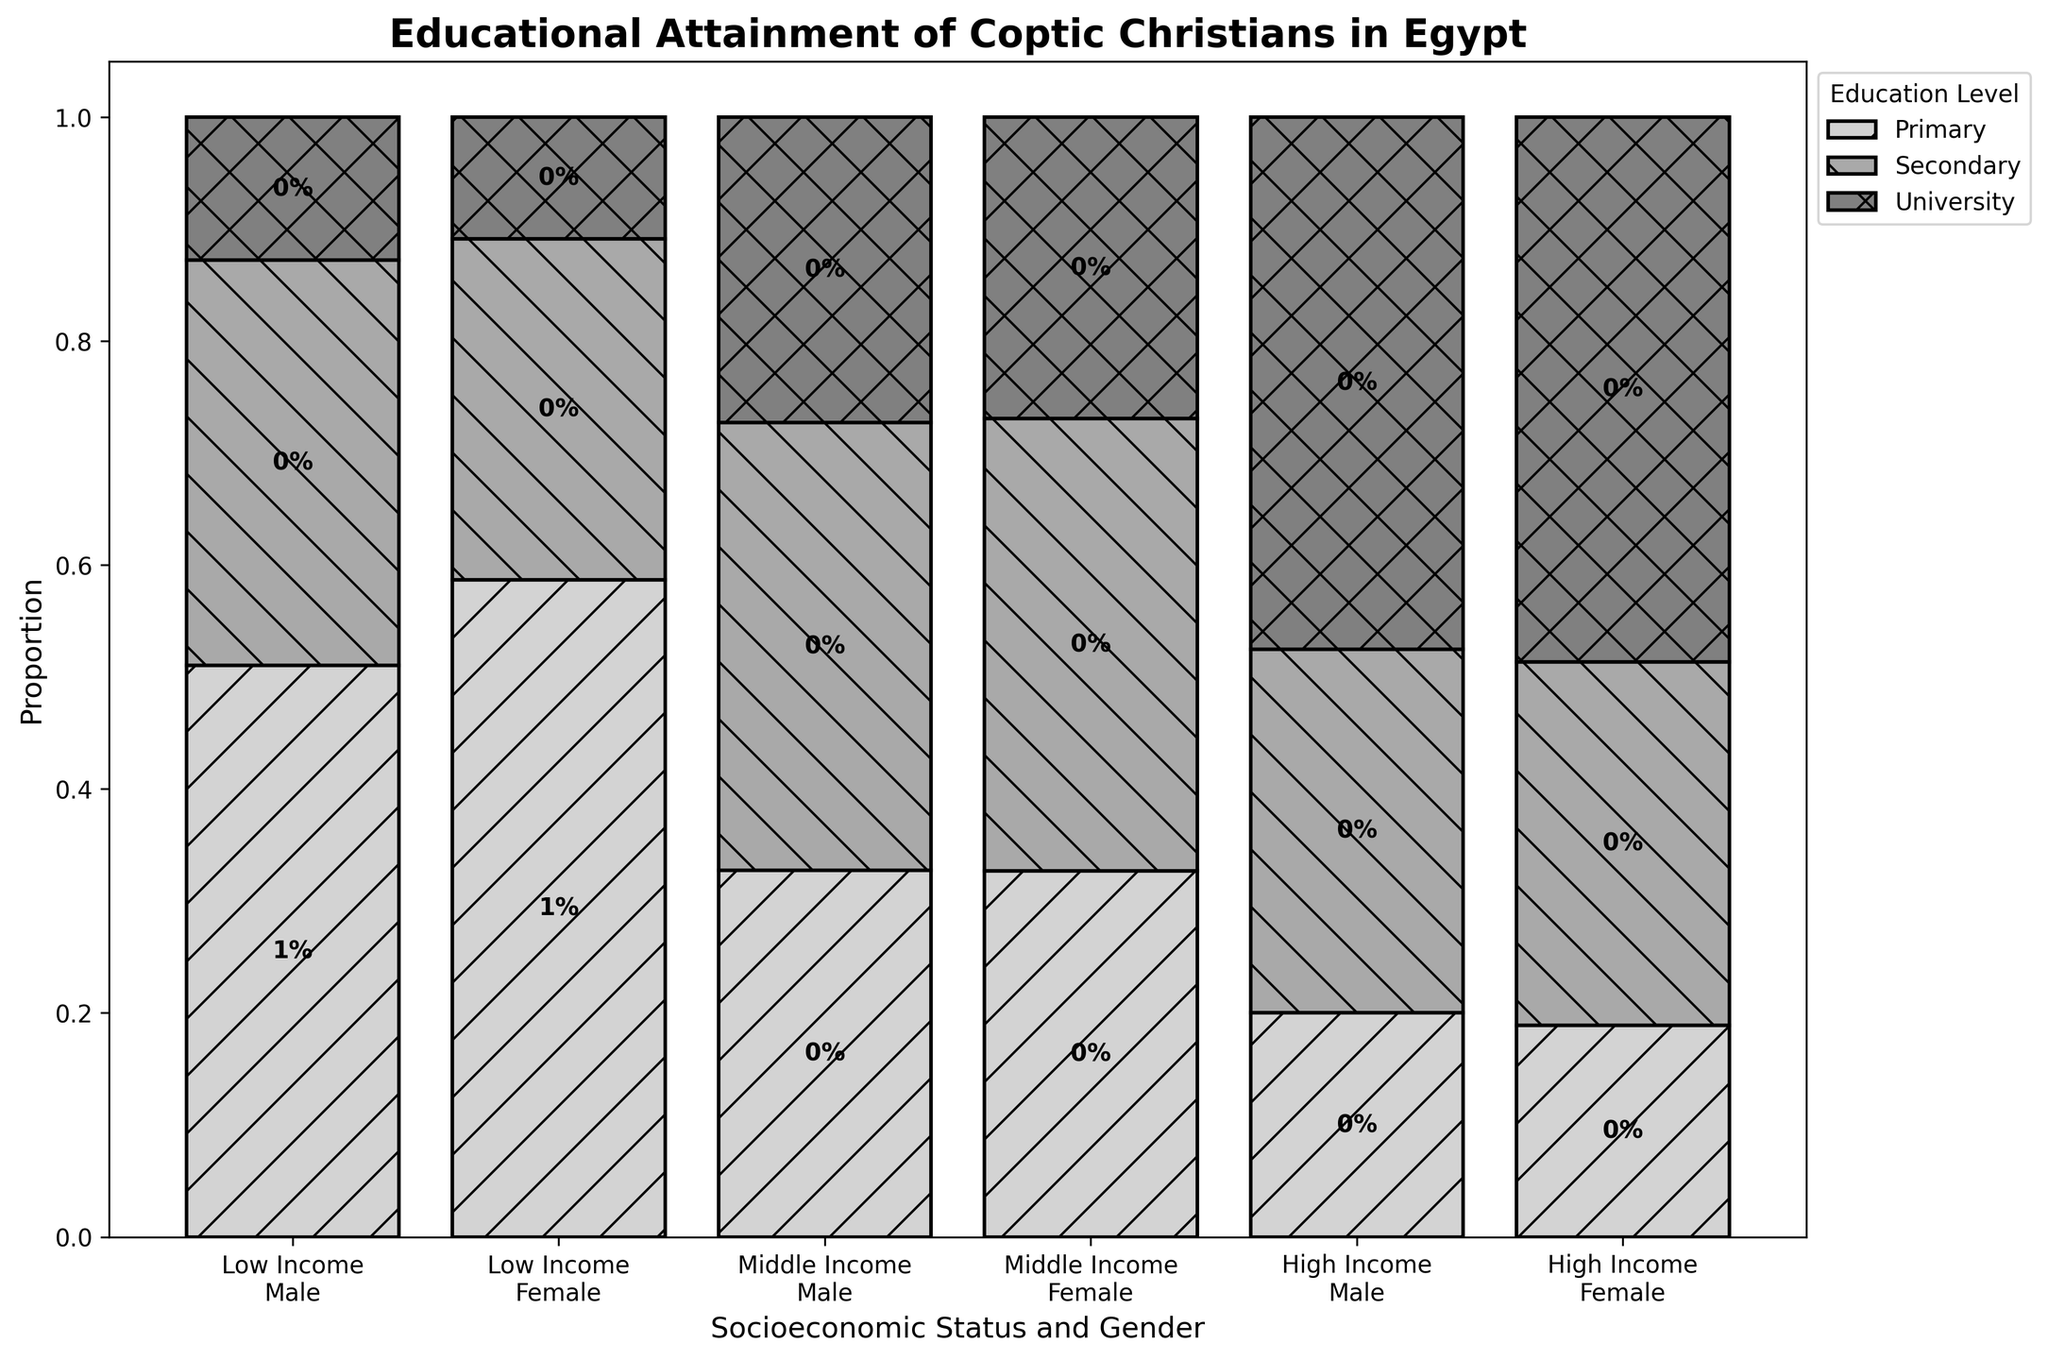What title is displayed at the top of the figure? The title of the figure is displayed at the top and provides an overview of what the plot represents. It helps the viewer understand the primary focus of the plot.
Answer: Educational Attainment of Coptic Christians in Egypt What does the x-axis of the plot represent? The x-axis of the plot shows the combination of socioeconomic status and gender. It differentiates the categories by indicating various statuses like 'Low Income', 'Middle Income', and 'High Income' alongside 'Male' and 'Female'.
Answer: Socioeconomic Status and Gender Which gender within the high-income group has the higher proportion of individuals with a university education? By examining the proportions in the high-income group, we compare the segments representing university education for both males and females.
Answer: Female In the middle-income group, which education level has the smallest proportion for males? We look at the segments representing different education levels within the middle-income group for males and identify the smallest segment.
Answer: Primary How does the proportion of primary education compare between low-income males and low-income females? We compare the height (or proportion) of the primary education segment in the low-income category for both males and females to see which is larger.
Answer: Females have a higher proportion What is the combined proportion of secondary and university education among middle-income males? Adding the proportions of secondary and university education segments for middle-income males gives us the combined total for these levels.
Answer: Approximately 67% Comparing low-income individuals, which gender has a greater total proportion across all education levels? By summing the proportions of primary, secondary, and university education for both males and females in the low-income group, we can determine which gender has a greater total proportion.
Answer: Males Which group has the smallest proportion of individuals with secondary education? By evaluating the secondary education segments across all categories, we identify the group with the smallest proportion.
Answer: Low-income females How does the proportion of university-educated individuals compare between high-income males and middle-income females? By comparing the height of the university education segment for high-income males and middle-income females, we see which group has a larger proportion.
Answer: High-income males What can be inferred about the relationship between socioeconomic status and educational attainment among Coptic Christians in Egypt? By observing the pattern in the plot, we infer that higher socioeconomic status tends to correlate with higher educational attainment levels across both genders.
Answer: Higher socioeconomic status correlates with higher education levels 